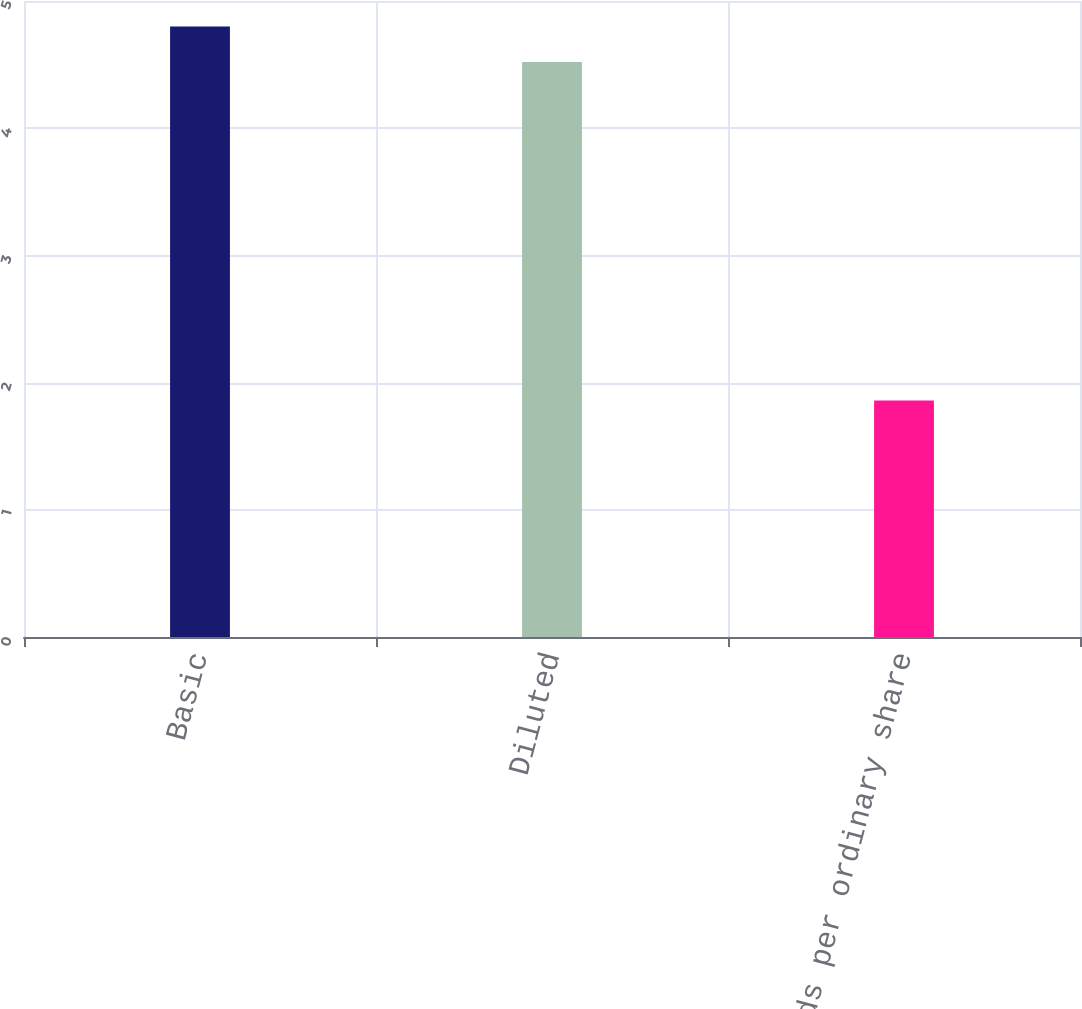Convert chart to OTSL. <chart><loc_0><loc_0><loc_500><loc_500><bar_chart><fcel>Basic<fcel>Diluted<fcel>Dividends per ordinary share<nl><fcel>4.8<fcel>4.52<fcel>1.86<nl></chart> 